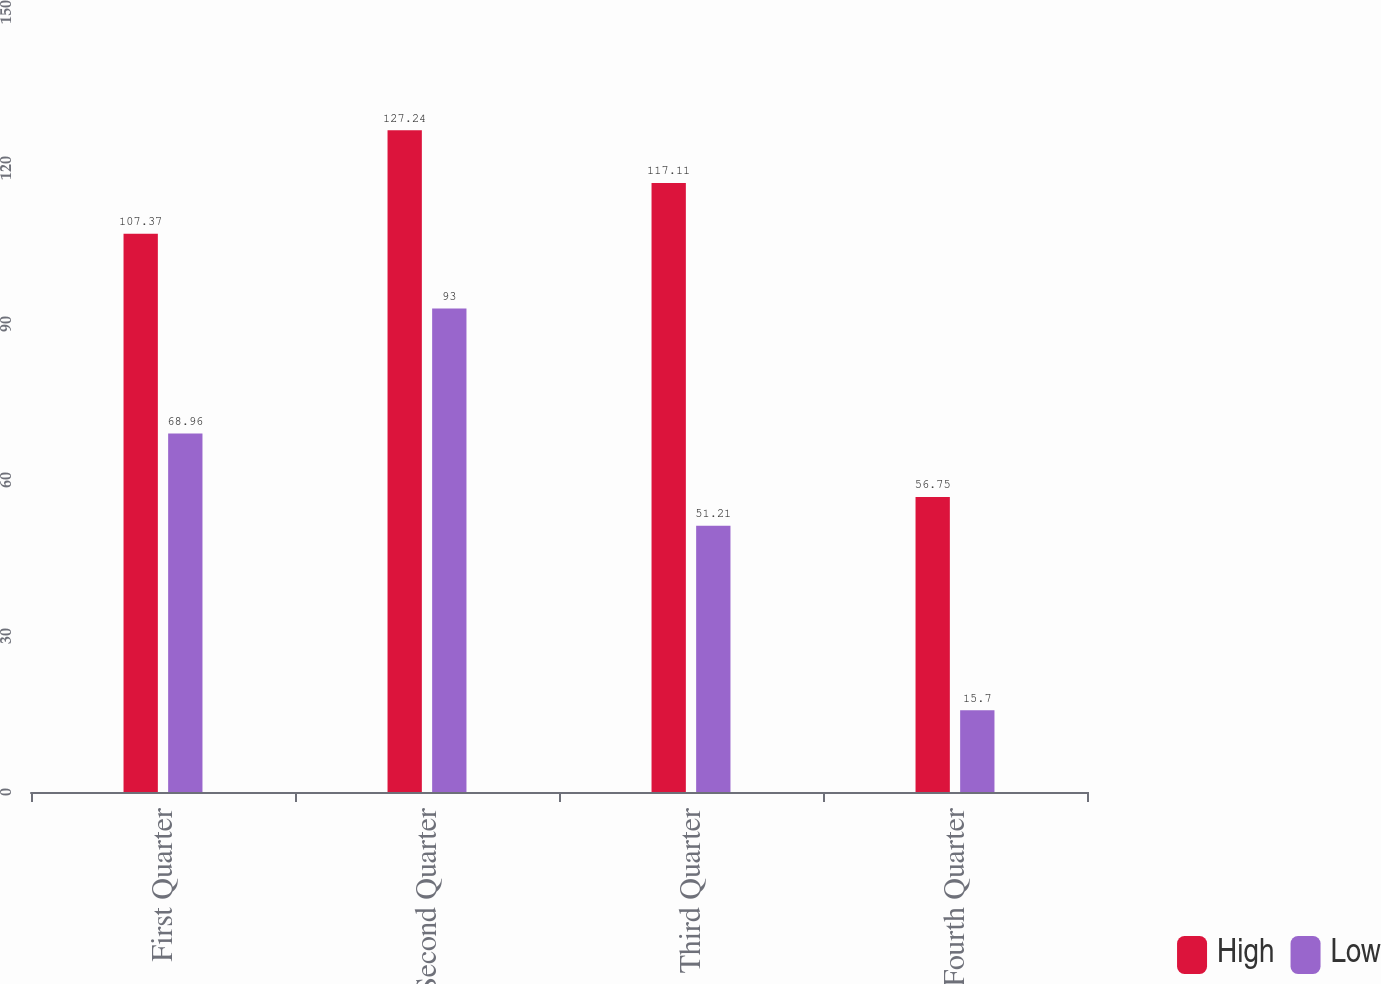Convert chart. <chart><loc_0><loc_0><loc_500><loc_500><stacked_bar_chart><ecel><fcel>First Quarter<fcel>Second Quarter<fcel>Third Quarter<fcel>Fourth Quarter<nl><fcel>High<fcel>107.37<fcel>127.24<fcel>117.11<fcel>56.75<nl><fcel>Low<fcel>68.96<fcel>93<fcel>51.21<fcel>15.7<nl></chart> 